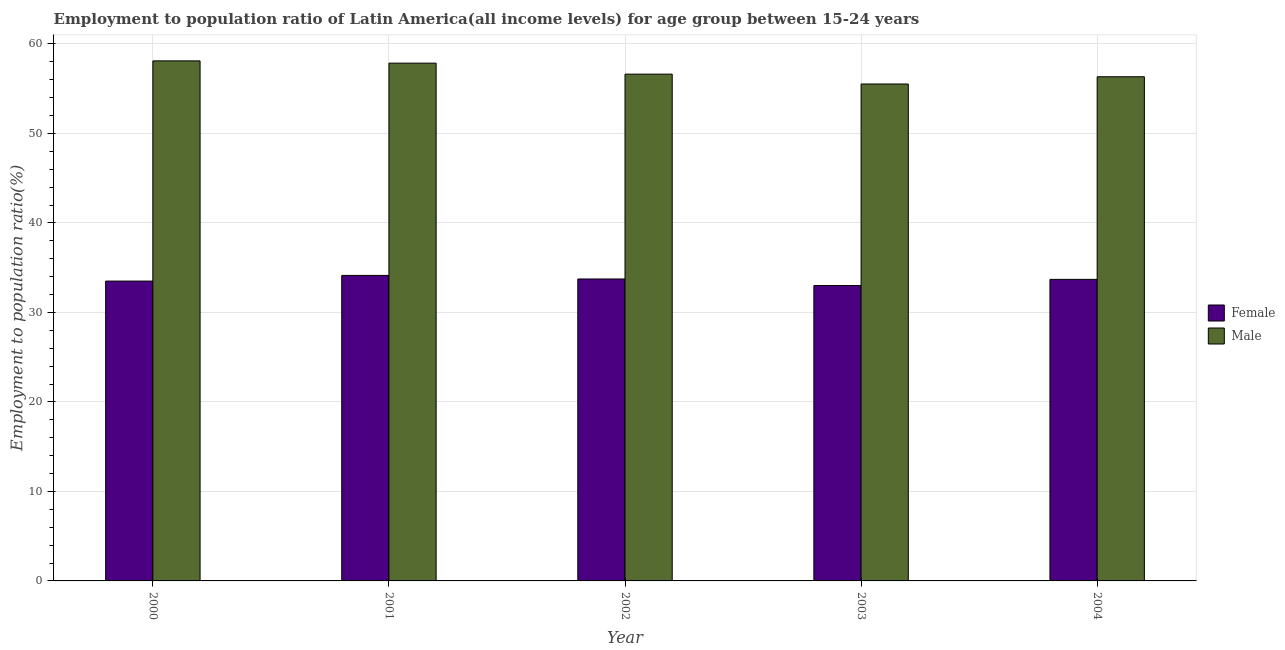Are the number of bars per tick equal to the number of legend labels?
Your response must be concise. Yes. How many bars are there on the 5th tick from the left?
Make the answer very short. 2. How many bars are there on the 5th tick from the right?
Offer a terse response. 2. In how many cases, is the number of bars for a given year not equal to the number of legend labels?
Your response must be concise. 0. What is the employment to population ratio(male) in 2004?
Your response must be concise. 56.33. Across all years, what is the maximum employment to population ratio(female)?
Make the answer very short. 34.13. Across all years, what is the minimum employment to population ratio(female)?
Offer a terse response. 33. What is the total employment to population ratio(female) in the graph?
Provide a short and direct response. 168.06. What is the difference between the employment to population ratio(male) in 2002 and that in 2004?
Your answer should be very brief. 0.29. What is the difference between the employment to population ratio(male) in 2004 and the employment to population ratio(female) in 2003?
Offer a terse response. 0.81. What is the average employment to population ratio(female) per year?
Your answer should be compact. 33.61. What is the ratio of the employment to population ratio(male) in 2001 to that in 2004?
Provide a succinct answer. 1.03. Is the difference between the employment to population ratio(female) in 2000 and 2002 greater than the difference between the employment to population ratio(male) in 2000 and 2002?
Ensure brevity in your answer.  No. What is the difference between the highest and the second highest employment to population ratio(male)?
Ensure brevity in your answer.  0.25. What is the difference between the highest and the lowest employment to population ratio(male)?
Provide a succinct answer. 2.58. In how many years, is the employment to population ratio(female) greater than the average employment to population ratio(female) taken over all years?
Give a very brief answer. 3. What does the 1st bar from the right in 2001 represents?
Provide a short and direct response. Male. How many bars are there?
Offer a terse response. 10. How many years are there in the graph?
Give a very brief answer. 5. Are the values on the major ticks of Y-axis written in scientific E-notation?
Ensure brevity in your answer.  No. Does the graph contain any zero values?
Offer a terse response. No. How are the legend labels stacked?
Your answer should be very brief. Vertical. What is the title of the graph?
Ensure brevity in your answer.  Employment to population ratio of Latin America(all income levels) for age group between 15-24 years. Does "GDP" appear as one of the legend labels in the graph?
Offer a terse response. No. What is the label or title of the Y-axis?
Your answer should be very brief. Employment to population ratio(%). What is the Employment to population ratio(%) in Female in 2000?
Ensure brevity in your answer.  33.5. What is the Employment to population ratio(%) of Male in 2000?
Make the answer very short. 58.11. What is the Employment to population ratio(%) of Female in 2001?
Provide a succinct answer. 34.13. What is the Employment to population ratio(%) of Male in 2001?
Offer a very short reply. 57.85. What is the Employment to population ratio(%) of Female in 2002?
Your answer should be compact. 33.74. What is the Employment to population ratio(%) of Male in 2002?
Make the answer very short. 56.62. What is the Employment to population ratio(%) in Female in 2003?
Ensure brevity in your answer.  33. What is the Employment to population ratio(%) in Male in 2003?
Your answer should be very brief. 55.52. What is the Employment to population ratio(%) of Female in 2004?
Offer a very short reply. 33.69. What is the Employment to population ratio(%) in Male in 2004?
Your response must be concise. 56.33. Across all years, what is the maximum Employment to population ratio(%) of Female?
Make the answer very short. 34.13. Across all years, what is the maximum Employment to population ratio(%) in Male?
Make the answer very short. 58.11. Across all years, what is the minimum Employment to population ratio(%) in Female?
Provide a short and direct response. 33. Across all years, what is the minimum Employment to population ratio(%) of Male?
Make the answer very short. 55.52. What is the total Employment to population ratio(%) of Female in the graph?
Offer a terse response. 168.06. What is the total Employment to population ratio(%) of Male in the graph?
Give a very brief answer. 284.43. What is the difference between the Employment to population ratio(%) of Female in 2000 and that in 2001?
Make the answer very short. -0.63. What is the difference between the Employment to population ratio(%) in Male in 2000 and that in 2001?
Your response must be concise. 0.25. What is the difference between the Employment to population ratio(%) of Female in 2000 and that in 2002?
Give a very brief answer. -0.24. What is the difference between the Employment to population ratio(%) of Male in 2000 and that in 2002?
Your response must be concise. 1.48. What is the difference between the Employment to population ratio(%) in Female in 2000 and that in 2003?
Keep it short and to the point. 0.5. What is the difference between the Employment to population ratio(%) in Male in 2000 and that in 2003?
Ensure brevity in your answer.  2.58. What is the difference between the Employment to population ratio(%) in Female in 2000 and that in 2004?
Your answer should be compact. -0.19. What is the difference between the Employment to population ratio(%) of Male in 2000 and that in 2004?
Make the answer very short. 1.77. What is the difference between the Employment to population ratio(%) of Female in 2001 and that in 2002?
Provide a short and direct response. 0.4. What is the difference between the Employment to population ratio(%) in Male in 2001 and that in 2002?
Give a very brief answer. 1.23. What is the difference between the Employment to population ratio(%) of Female in 2001 and that in 2003?
Ensure brevity in your answer.  1.13. What is the difference between the Employment to population ratio(%) of Male in 2001 and that in 2003?
Keep it short and to the point. 2.33. What is the difference between the Employment to population ratio(%) of Female in 2001 and that in 2004?
Offer a very short reply. 0.44. What is the difference between the Employment to population ratio(%) of Male in 2001 and that in 2004?
Your answer should be compact. 1.52. What is the difference between the Employment to population ratio(%) in Female in 2002 and that in 2003?
Give a very brief answer. 0.73. What is the difference between the Employment to population ratio(%) of Male in 2002 and that in 2003?
Give a very brief answer. 1.1. What is the difference between the Employment to population ratio(%) in Female in 2002 and that in 2004?
Your answer should be compact. 0.04. What is the difference between the Employment to population ratio(%) in Male in 2002 and that in 2004?
Offer a terse response. 0.29. What is the difference between the Employment to population ratio(%) of Female in 2003 and that in 2004?
Your answer should be very brief. -0.69. What is the difference between the Employment to population ratio(%) in Male in 2003 and that in 2004?
Keep it short and to the point. -0.81. What is the difference between the Employment to population ratio(%) in Female in 2000 and the Employment to population ratio(%) in Male in 2001?
Your answer should be very brief. -24.35. What is the difference between the Employment to population ratio(%) in Female in 2000 and the Employment to population ratio(%) in Male in 2002?
Make the answer very short. -23.12. What is the difference between the Employment to population ratio(%) in Female in 2000 and the Employment to population ratio(%) in Male in 2003?
Offer a terse response. -22.02. What is the difference between the Employment to population ratio(%) in Female in 2000 and the Employment to population ratio(%) in Male in 2004?
Ensure brevity in your answer.  -22.83. What is the difference between the Employment to population ratio(%) of Female in 2001 and the Employment to population ratio(%) of Male in 2002?
Provide a succinct answer. -22.49. What is the difference between the Employment to population ratio(%) of Female in 2001 and the Employment to population ratio(%) of Male in 2003?
Your response must be concise. -21.39. What is the difference between the Employment to population ratio(%) in Female in 2001 and the Employment to population ratio(%) in Male in 2004?
Keep it short and to the point. -22.2. What is the difference between the Employment to population ratio(%) in Female in 2002 and the Employment to population ratio(%) in Male in 2003?
Provide a short and direct response. -21.79. What is the difference between the Employment to population ratio(%) in Female in 2002 and the Employment to population ratio(%) in Male in 2004?
Give a very brief answer. -22.59. What is the difference between the Employment to population ratio(%) of Female in 2003 and the Employment to population ratio(%) of Male in 2004?
Your answer should be very brief. -23.33. What is the average Employment to population ratio(%) in Female per year?
Keep it short and to the point. 33.61. What is the average Employment to population ratio(%) in Male per year?
Keep it short and to the point. 56.89. In the year 2000, what is the difference between the Employment to population ratio(%) of Female and Employment to population ratio(%) of Male?
Provide a short and direct response. -24.6. In the year 2001, what is the difference between the Employment to population ratio(%) of Female and Employment to population ratio(%) of Male?
Your answer should be very brief. -23.72. In the year 2002, what is the difference between the Employment to population ratio(%) of Female and Employment to population ratio(%) of Male?
Your response must be concise. -22.89. In the year 2003, what is the difference between the Employment to population ratio(%) in Female and Employment to population ratio(%) in Male?
Provide a succinct answer. -22.52. In the year 2004, what is the difference between the Employment to population ratio(%) in Female and Employment to population ratio(%) in Male?
Provide a succinct answer. -22.64. What is the ratio of the Employment to population ratio(%) of Female in 2000 to that in 2001?
Make the answer very short. 0.98. What is the ratio of the Employment to population ratio(%) in Male in 2000 to that in 2001?
Ensure brevity in your answer.  1. What is the ratio of the Employment to population ratio(%) of Male in 2000 to that in 2002?
Your answer should be very brief. 1.03. What is the ratio of the Employment to population ratio(%) in Female in 2000 to that in 2003?
Ensure brevity in your answer.  1.02. What is the ratio of the Employment to population ratio(%) of Male in 2000 to that in 2003?
Make the answer very short. 1.05. What is the ratio of the Employment to population ratio(%) of Male in 2000 to that in 2004?
Offer a terse response. 1.03. What is the ratio of the Employment to population ratio(%) in Female in 2001 to that in 2002?
Your answer should be compact. 1.01. What is the ratio of the Employment to population ratio(%) in Male in 2001 to that in 2002?
Ensure brevity in your answer.  1.02. What is the ratio of the Employment to population ratio(%) in Female in 2001 to that in 2003?
Keep it short and to the point. 1.03. What is the ratio of the Employment to population ratio(%) of Male in 2001 to that in 2003?
Your response must be concise. 1.04. What is the ratio of the Employment to population ratio(%) of Female in 2001 to that in 2004?
Give a very brief answer. 1.01. What is the ratio of the Employment to population ratio(%) in Female in 2002 to that in 2003?
Offer a very short reply. 1.02. What is the ratio of the Employment to population ratio(%) of Male in 2002 to that in 2003?
Ensure brevity in your answer.  1.02. What is the ratio of the Employment to population ratio(%) in Female in 2003 to that in 2004?
Make the answer very short. 0.98. What is the ratio of the Employment to population ratio(%) of Male in 2003 to that in 2004?
Offer a terse response. 0.99. What is the difference between the highest and the second highest Employment to population ratio(%) in Female?
Your answer should be compact. 0.4. What is the difference between the highest and the second highest Employment to population ratio(%) of Male?
Make the answer very short. 0.25. What is the difference between the highest and the lowest Employment to population ratio(%) of Female?
Provide a short and direct response. 1.13. What is the difference between the highest and the lowest Employment to population ratio(%) in Male?
Provide a short and direct response. 2.58. 